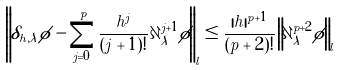<formula> <loc_0><loc_0><loc_500><loc_500>\left \| \delta _ { h , \lambda } \phi - \sum _ { j = 0 } ^ { p } \frac { h ^ { j } } { ( j + 1 ) ! } \partial _ { \lambda } ^ { j + 1 } \phi \right \| _ { l } \leq \frac { | h | ^ { p + 1 } } { ( p + 2 ) ! } \left \| \partial _ { \lambda } ^ { p + 2 } \phi \right \| _ { l }</formula> 